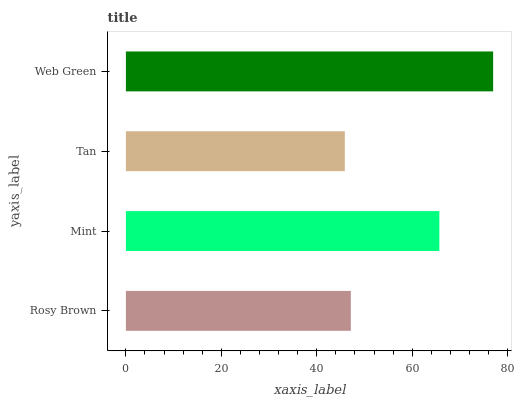Is Tan the minimum?
Answer yes or no. Yes. Is Web Green the maximum?
Answer yes or no. Yes. Is Mint the minimum?
Answer yes or no. No. Is Mint the maximum?
Answer yes or no. No. Is Mint greater than Rosy Brown?
Answer yes or no. Yes. Is Rosy Brown less than Mint?
Answer yes or no. Yes. Is Rosy Brown greater than Mint?
Answer yes or no. No. Is Mint less than Rosy Brown?
Answer yes or no. No. Is Mint the high median?
Answer yes or no. Yes. Is Rosy Brown the low median?
Answer yes or no. Yes. Is Rosy Brown the high median?
Answer yes or no. No. Is Web Green the low median?
Answer yes or no. No. 